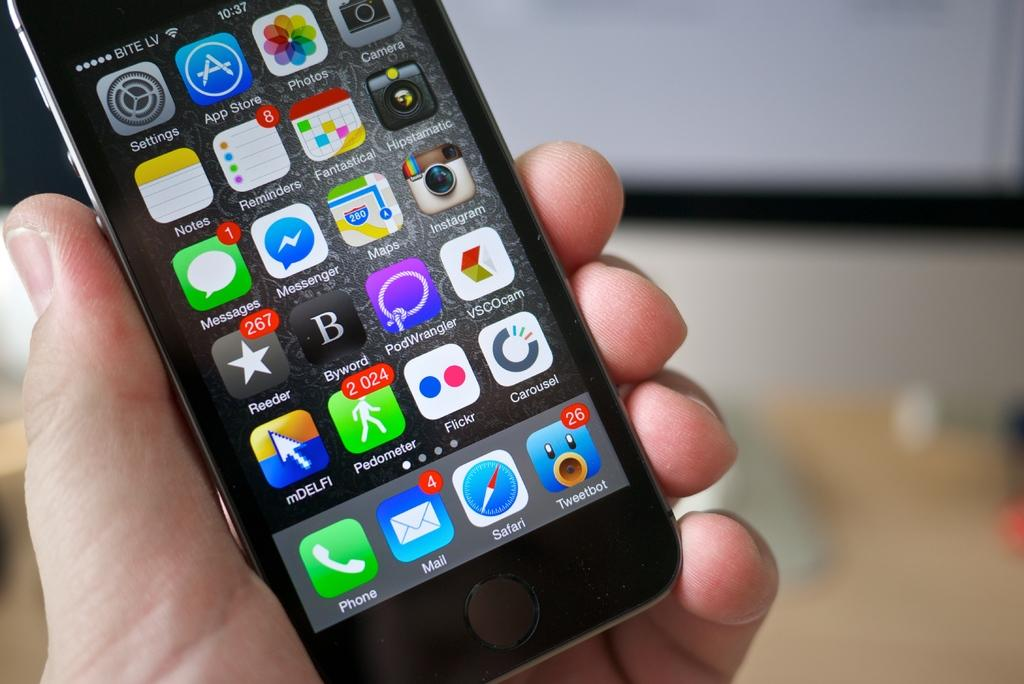What is the human hand holding in the image? The human hand is holding a mobile in the image. What color is the mobile? The mobile is black in color. What can be seen on the mobile screen? There are icons visible on the mobile screen. Can you describe the background of the image? The background of the image is blurry. Are there any trees visible in the image? There are no trees present in the image; it features a human hand holding a black mobile with icons on the screen and a blurry background. 